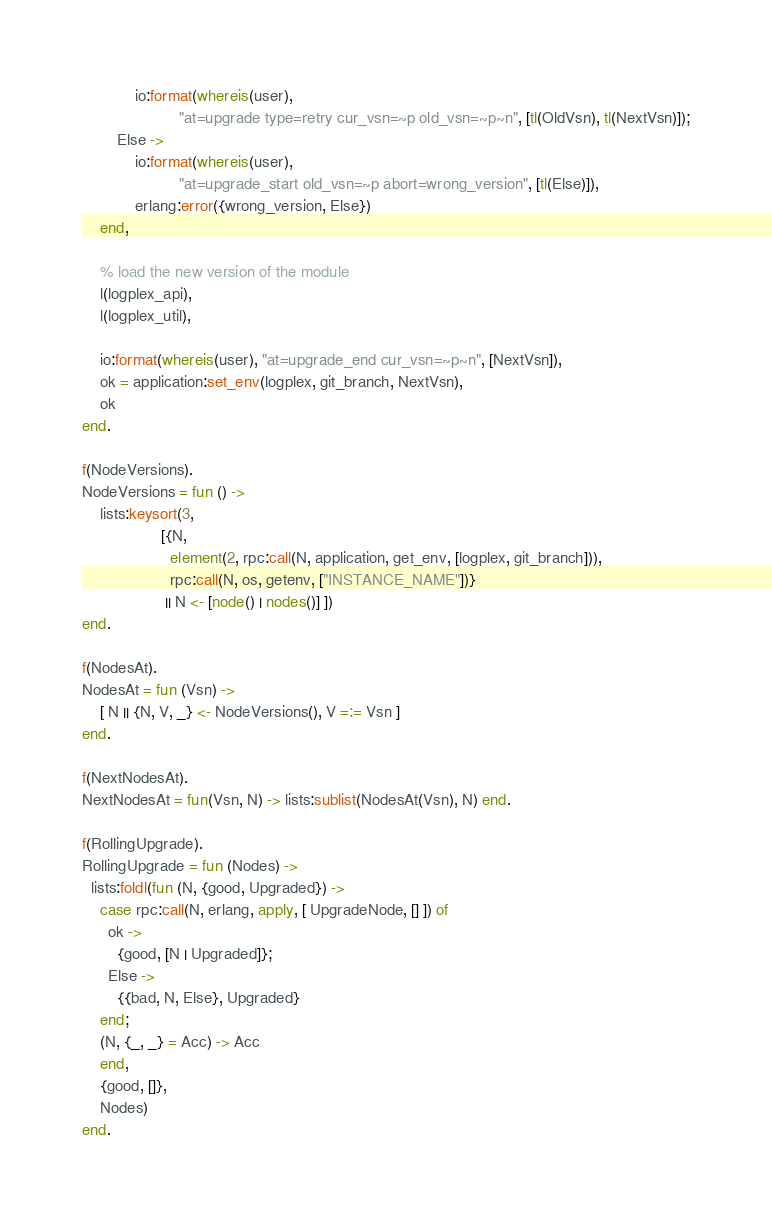Convert code to text. <code><loc_0><loc_0><loc_500><loc_500><_Erlang_>            io:format(whereis(user),
                      "at=upgrade type=retry cur_vsn=~p old_vsn=~p~n", [tl(OldVsn), tl(NextVsn)]);
        Else ->
            io:format(whereis(user),
                      "at=upgrade_start old_vsn=~p abort=wrong_version", [tl(Else)]),
            erlang:error({wrong_version, Else})
    end,

    % load the new version of the module
    l(logplex_api),
    l(logplex_util),

    io:format(whereis(user), "at=upgrade_end cur_vsn=~p~n", [NextVsn]),
    ok = application:set_env(logplex, git_branch, NextVsn),
    ok
end.

f(NodeVersions).
NodeVersions = fun () ->
    lists:keysort(3,
                  [{N,
                    element(2, rpc:call(N, application, get_env, [logplex, git_branch])),
                    rpc:call(N, os, getenv, ["INSTANCE_NAME"])}
                   || N <- [node() | nodes()] ])
end.

f(NodesAt).
NodesAt = fun (Vsn) ->
    [ N || {N, V, _} <- NodeVersions(), V =:= Vsn ]
end.

f(NextNodesAt).
NextNodesAt = fun(Vsn, N) -> lists:sublist(NodesAt(Vsn), N) end.

f(RollingUpgrade).
RollingUpgrade = fun (Nodes) ->
  lists:foldl(fun (N, {good, Upgraded}) ->
    case rpc:call(N, erlang, apply, [ UpgradeNode, [] ]) of
      ok ->
        {good, [N | Upgraded]};
      Else ->
        {{bad, N, Else}, Upgraded}
    end;
    (N, {_, _} = Acc) -> Acc
    end,
    {good, []},
    Nodes)
end.
</code> 